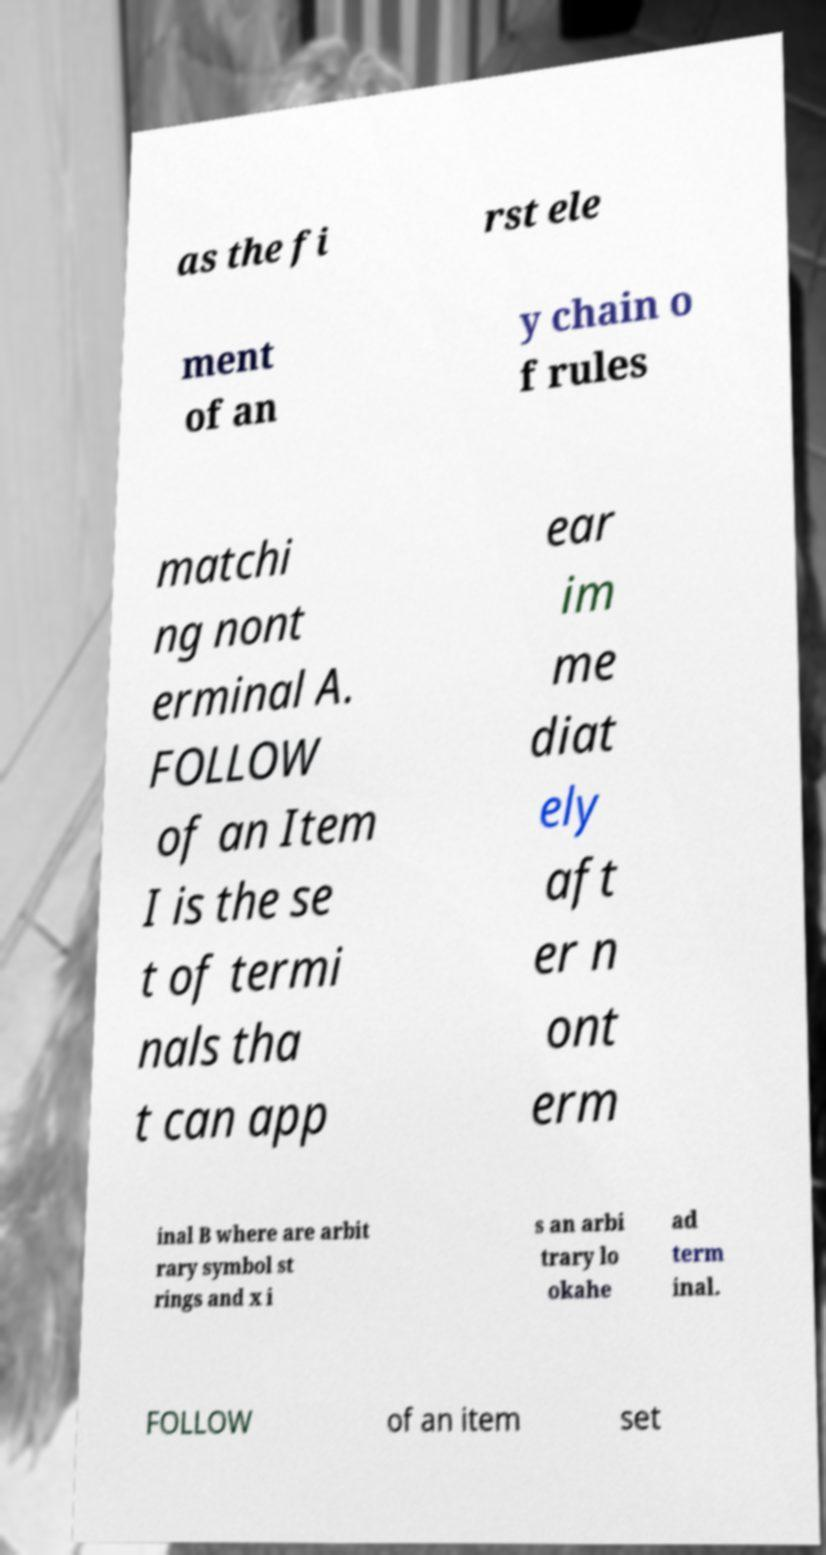There's text embedded in this image that I need extracted. Can you transcribe it verbatim? as the fi rst ele ment of an y chain o f rules matchi ng nont erminal A. FOLLOW of an Item I is the se t of termi nals tha t can app ear im me diat ely aft er n ont erm inal B where are arbit rary symbol st rings and x i s an arbi trary lo okahe ad term inal. FOLLOW of an item set 